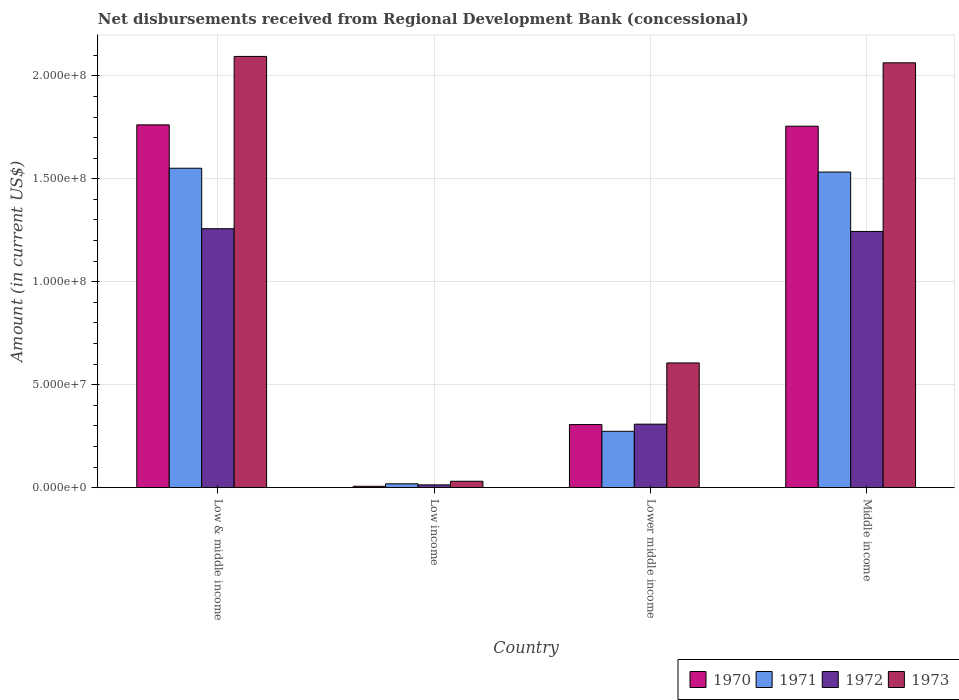How many different coloured bars are there?
Keep it short and to the point. 4. How many groups of bars are there?
Make the answer very short. 4. How many bars are there on the 2nd tick from the left?
Your answer should be compact. 4. How many bars are there on the 3rd tick from the right?
Keep it short and to the point. 4. What is the amount of disbursements received from Regional Development Bank in 1971 in Low & middle income?
Provide a succinct answer. 1.55e+08. Across all countries, what is the maximum amount of disbursements received from Regional Development Bank in 1970?
Make the answer very short. 1.76e+08. Across all countries, what is the minimum amount of disbursements received from Regional Development Bank in 1971?
Offer a very short reply. 1.86e+06. In which country was the amount of disbursements received from Regional Development Bank in 1973 maximum?
Keep it short and to the point. Low & middle income. What is the total amount of disbursements received from Regional Development Bank in 1972 in the graph?
Ensure brevity in your answer.  2.82e+08. What is the difference between the amount of disbursements received from Regional Development Bank in 1973 in Low & middle income and that in Low income?
Give a very brief answer. 2.06e+08. What is the difference between the amount of disbursements received from Regional Development Bank in 1970 in Low income and the amount of disbursements received from Regional Development Bank in 1972 in Low & middle income?
Provide a short and direct response. -1.25e+08. What is the average amount of disbursements received from Regional Development Bank in 1970 per country?
Your answer should be very brief. 9.58e+07. What is the difference between the amount of disbursements received from Regional Development Bank of/in 1973 and amount of disbursements received from Regional Development Bank of/in 1972 in Low & middle income?
Provide a succinct answer. 8.37e+07. In how many countries, is the amount of disbursements received from Regional Development Bank in 1971 greater than 120000000 US$?
Give a very brief answer. 2. What is the ratio of the amount of disbursements received from Regional Development Bank in 1973 in Low & middle income to that in Lower middle income?
Provide a short and direct response. 3.46. Is the amount of disbursements received from Regional Development Bank in 1970 in Low & middle income less than that in Low income?
Keep it short and to the point. No. Is the difference between the amount of disbursements received from Regional Development Bank in 1973 in Low & middle income and Middle income greater than the difference between the amount of disbursements received from Regional Development Bank in 1972 in Low & middle income and Middle income?
Make the answer very short. Yes. What is the difference between the highest and the second highest amount of disbursements received from Regional Development Bank in 1973?
Offer a very short reply. 3.09e+06. What is the difference between the highest and the lowest amount of disbursements received from Regional Development Bank in 1973?
Provide a succinct answer. 2.06e+08. Is it the case that in every country, the sum of the amount of disbursements received from Regional Development Bank in 1970 and amount of disbursements received from Regional Development Bank in 1973 is greater than the sum of amount of disbursements received from Regional Development Bank in 1972 and amount of disbursements received from Regional Development Bank in 1971?
Your answer should be compact. No. What does the 2nd bar from the left in Low income represents?
Provide a succinct answer. 1971. Is it the case that in every country, the sum of the amount of disbursements received from Regional Development Bank in 1970 and amount of disbursements received from Regional Development Bank in 1973 is greater than the amount of disbursements received from Regional Development Bank in 1972?
Your answer should be compact. Yes. Are all the bars in the graph horizontal?
Provide a short and direct response. No. How many legend labels are there?
Give a very brief answer. 4. How are the legend labels stacked?
Offer a terse response. Horizontal. What is the title of the graph?
Your answer should be compact. Net disbursements received from Regional Development Bank (concessional). Does "1996" appear as one of the legend labels in the graph?
Make the answer very short. No. What is the Amount (in current US$) in 1970 in Low & middle income?
Provide a short and direct response. 1.76e+08. What is the Amount (in current US$) in 1971 in Low & middle income?
Your answer should be very brief. 1.55e+08. What is the Amount (in current US$) in 1972 in Low & middle income?
Offer a terse response. 1.26e+08. What is the Amount (in current US$) in 1973 in Low & middle income?
Make the answer very short. 2.09e+08. What is the Amount (in current US$) in 1970 in Low income?
Make the answer very short. 6.47e+05. What is the Amount (in current US$) of 1971 in Low income?
Your answer should be very brief. 1.86e+06. What is the Amount (in current US$) of 1972 in Low income?
Your answer should be compact. 1.33e+06. What is the Amount (in current US$) of 1973 in Low income?
Keep it short and to the point. 3.09e+06. What is the Amount (in current US$) in 1970 in Lower middle income?
Ensure brevity in your answer.  3.06e+07. What is the Amount (in current US$) of 1971 in Lower middle income?
Give a very brief answer. 2.74e+07. What is the Amount (in current US$) in 1972 in Lower middle income?
Offer a terse response. 3.08e+07. What is the Amount (in current US$) in 1973 in Lower middle income?
Your answer should be very brief. 6.06e+07. What is the Amount (in current US$) of 1970 in Middle income?
Make the answer very short. 1.76e+08. What is the Amount (in current US$) of 1971 in Middle income?
Your answer should be compact. 1.53e+08. What is the Amount (in current US$) in 1972 in Middle income?
Offer a very short reply. 1.24e+08. What is the Amount (in current US$) in 1973 in Middle income?
Ensure brevity in your answer.  2.06e+08. Across all countries, what is the maximum Amount (in current US$) of 1970?
Offer a terse response. 1.76e+08. Across all countries, what is the maximum Amount (in current US$) in 1971?
Ensure brevity in your answer.  1.55e+08. Across all countries, what is the maximum Amount (in current US$) of 1972?
Keep it short and to the point. 1.26e+08. Across all countries, what is the maximum Amount (in current US$) of 1973?
Give a very brief answer. 2.09e+08. Across all countries, what is the minimum Amount (in current US$) of 1970?
Offer a very short reply. 6.47e+05. Across all countries, what is the minimum Amount (in current US$) of 1971?
Ensure brevity in your answer.  1.86e+06. Across all countries, what is the minimum Amount (in current US$) of 1972?
Your answer should be very brief. 1.33e+06. Across all countries, what is the minimum Amount (in current US$) of 1973?
Your answer should be very brief. 3.09e+06. What is the total Amount (in current US$) in 1970 in the graph?
Provide a short and direct response. 3.83e+08. What is the total Amount (in current US$) in 1971 in the graph?
Keep it short and to the point. 3.38e+08. What is the total Amount (in current US$) in 1972 in the graph?
Offer a terse response. 2.82e+08. What is the total Amount (in current US$) of 1973 in the graph?
Give a very brief answer. 4.79e+08. What is the difference between the Amount (in current US$) of 1970 in Low & middle income and that in Low income?
Give a very brief answer. 1.76e+08. What is the difference between the Amount (in current US$) of 1971 in Low & middle income and that in Low income?
Your answer should be very brief. 1.53e+08. What is the difference between the Amount (in current US$) in 1972 in Low & middle income and that in Low income?
Your answer should be very brief. 1.24e+08. What is the difference between the Amount (in current US$) in 1973 in Low & middle income and that in Low income?
Provide a succinct answer. 2.06e+08. What is the difference between the Amount (in current US$) in 1970 in Low & middle income and that in Lower middle income?
Your answer should be compact. 1.46e+08. What is the difference between the Amount (in current US$) in 1971 in Low & middle income and that in Lower middle income?
Your answer should be compact. 1.28e+08. What is the difference between the Amount (in current US$) of 1972 in Low & middle income and that in Lower middle income?
Provide a short and direct response. 9.49e+07. What is the difference between the Amount (in current US$) in 1973 in Low & middle income and that in Lower middle income?
Provide a succinct answer. 1.49e+08. What is the difference between the Amount (in current US$) in 1970 in Low & middle income and that in Middle income?
Keep it short and to the point. 6.47e+05. What is the difference between the Amount (in current US$) in 1971 in Low & middle income and that in Middle income?
Ensure brevity in your answer.  1.86e+06. What is the difference between the Amount (in current US$) of 1972 in Low & middle income and that in Middle income?
Your answer should be compact. 1.33e+06. What is the difference between the Amount (in current US$) of 1973 in Low & middle income and that in Middle income?
Provide a short and direct response. 3.09e+06. What is the difference between the Amount (in current US$) in 1970 in Low income and that in Lower middle income?
Your answer should be compact. -3.00e+07. What is the difference between the Amount (in current US$) of 1971 in Low income and that in Lower middle income?
Ensure brevity in your answer.  -2.55e+07. What is the difference between the Amount (in current US$) of 1972 in Low income and that in Lower middle income?
Your answer should be compact. -2.95e+07. What is the difference between the Amount (in current US$) of 1973 in Low income and that in Lower middle income?
Your answer should be compact. -5.75e+07. What is the difference between the Amount (in current US$) in 1970 in Low income and that in Middle income?
Ensure brevity in your answer.  -1.75e+08. What is the difference between the Amount (in current US$) in 1971 in Low income and that in Middle income?
Offer a terse response. -1.51e+08. What is the difference between the Amount (in current US$) in 1972 in Low income and that in Middle income?
Provide a short and direct response. -1.23e+08. What is the difference between the Amount (in current US$) of 1973 in Low income and that in Middle income?
Your answer should be compact. -2.03e+08. What is the difference between the Amount (in current US$) of 1970 in Lower middle income and that in Middle income?
Offer a very short reply. -1.45e+08. What is the difference between the Amount (in current US$) of 1971 in Lower middle income and that in Middle income?
Give a very brief answer. -1.26e+08. What is the difference between the Amount (in current US$) in 1972 in Lower middle income and that in Middle income?
Your answer should be very brief. -9.36e+07. What is the difference between the Amount (in current US$) in 1973 in Lower middle income and that in Middle income?
Your answer should be very brief. -1.46e+08. What is the difference between the Amount (in current US$) in 1970 in Low & middle income and the Amount (in current US$) in 1971 in Low income?
Your response must be concise. 1.74e+08. What is the difference between the Amount (in current US$) of 1970 in Low & middle income and the Amount (in current US$) of 1972 in Low income?
Offer a very short reply. 1.75e+08. What is the difference between the Amount (in current US$) of 1970 in Low & middle income and the Amount (in current US$) of 1973 in Low income?
Provide a succinct answer. 1.73e+08. What is the difference between the Amount (in current US$) in 1971 in Low & middle income and the Amount (in current US$) in 1972 in Low income?
Your answer should be very brief. 1.54e+08. What is the difference between the Amount (in current US$) in 1971 in Low & middle income and the Amount (in current US$) in 1973 in Low income?
Your answer should be compact. 1.52e+08. What is the difference between the Amount (in current US$) in 1972 in Low & middle income and the Amount (in current US$) in 1973 in Low income?
Make the answer very short. 1.23e+08. What is the difference between the Amount (in current US$) of 1970 in Low & middle income and the Amount (in current US$) of 1971 in Lower middle income?
Offer a very short reply. 1.49e+08. What is the difference between the Amount (in current US$) in 1970 in Low & middle income and the Amount (in current US$) in 1972 in Lower middle income?
Your answer should be compact. 1.45e+08. What is the difference between the Amount (in current US$) of 1970 in Low & middle income and the Amount (in current US$) of 1973 in Lower middle income?
Make the answer very short. 1.16e+08. What is the difference between the Amount (in current US$) of 1971 in Low & middle income and the Amount (in current US$) of 1972 in Lower middle income?
Give a very brief answer. 1.24e+08. What is the difference between the Amount (in current US$) of 1971 in Low & middle income and the Amount (in current US$) of 1973 in Lower middle income?
Make the answer very short. 9.46e+07. What is the difference between the Amount (in current US$) in 1972 in Low & middle income and the Amount (in current US$) in 1973 in Lower middle income?
Provide a short and direct response. 6.52e+07. What is the difference between the Amount (in current US$) in 1970 in Low & middle income and the Amount (in current US$) in 1971 in Middle income?
Keep it short and to the point. 2.29e+07. What is the difference between the Amount (in current US$) in 1970 in Low & middle income and the Amount (in current US$) in 1972 in Middle income?
Give a very brief answer. 5.18e+07. What is the difference between the Amount (in current US$) of 1970 in Low & middle income and the Amount (in current US$) of 1973 in Middle income?
Provide a short and direct response. -3.01e+07. What is the difference between the Amount (in current US$) in 1971 in Low & middle income and the Amount (in current US$) in 1972 in Middle income?
Make the answer very short. 3.07e+07. What is the difference between the Amount (in current US$) in 1971 in Low & middle income and the Amount (in current US$) in 1973 in Middle income?
Make the answer very short. -5.12e+07. What is the difference between the Amount (in current US$) of 1972 in Low & middle income and the Amount (in current US$) of 1973 in Middle income?
Your response must be concise. -8.06e+07. What is the difference between the Amount (in current US$) in 1970 in Low income and the Amount (in current US$) in 1971 in Lower middle income?
Keep it short and to the point. -2.67e+07. What is the difference between the Amount (in current US$) of 1970 in Low income and the Amount (in current US$) of 1972 in Lower middle income?
Your answer should be very brief. -3.02e+07. What is the difference between the Amount (in current US$) of 1970 in Low income and the Amount (in current US$) of 1973 in Lower middle income?
Provide a short and direct response. -5.99e+07. What is the difference between the Amount (in current US$) of 1971 in Low income and the Amount (in current US$) of 1972 in Lower middle income?
Make the answer very short. -2.90e+07. What is the difference between the Amount (in current US$) in 1971 in Low income and the Amount (in current US$) in 1973 in Lower middle income?
Provide a short and direct response. -5.87e+07. What is the difference between the Amount (in current US$) of 1972 in Low income and the Amount (in current US$) of 1973 in Lower middle income?
Ensure brevity in your answer.  -5.92e+07. What is the difference between the Amount (in current US$) of 1970 in Low income and the Amount (in current US$) of 1971 in Middle income?
Provide a short and direct response. -1.53e+08. What is the difference between the Amount (in current US$) in 1970 in Low income and the Amount (in current US$) in 1972 in Middle income?
Your answer should be very brief. -1.24e+08. What is the difference between the Amount (in current US$) in 1970 in Low income and the Amount (in current US$) in 1973 in Middle income?
Offer a terse response. -2.06e+08. What is the difference between the Amount (in current US$) in 1971 in Low income and the Amount (in current US$) in 1972 in Middle income?
Offer a terse response. -1.23e+08. What is the difference between the Amount (in current US$) in 1971 in Low income and the Amount (in current US$) in 1973 in Middle income?
Offer a very short reply. -2.04e+08. What is the difference between the Amount (in current US$) of 1972 in Low income and the Amount (in current US$) of 1973 in Middle income?
Offer a terse response. -2.05e+08. What is the difference between the Amount (in current US$) in 1970 in Lower middle income and the Amount (in current US$) in 1971 in Middle income?
Ensure brevity in your answer.  -1.23e+08. What is the difference between the Amount (in current US$) in 1970 in Lower middle income and the Amount (in current US$) in 1972 in Middle income?
Make the answer very short. -9.38e+07. What is the difference between the Amount (in current US$) in 1970 in Lower middle income and the Amount (in current US$) in 1973 in Middle income?
Your answer should be compact. -1.76e+08. What is the difference between the Amount (in current US$) in 1971 in Lower middle income and the Amount (in current US$) in 1972 in Middle income?
Make the answer very short. -9.71e+07. What is the difference between the Amount (in current US$) in 1971 in Lower middle income and the Amount (in current US$) in 1973 in Middle income?
Make the answer very short. -1.79e+08. What is the difference between the Amount (in current US$) in 1972 in Lower middle income and the Amount (in current US$) in 1973 in Middle income?
Ensure brevity in your answer.  -1.76e+08. What is the average Amount (in current US$) of 1970 per country?
Your answer should be compact. 9.58e+07. What is the average Amount (in current US$) in 1971 per country?
Offer a terse response. 8.44e+07. What is the average Amount (in current US$) in 1972 per country?
Offer a terse response. 7.06e+07. What is the average Amount (in current US$) in 1973 per country?
Your response must be concise. 1.20e+08. What is the difference between the Amount (in current US$) of 1970 and Amount (in current US$) of 1971 in Low & middle income?
Your answer should be compact. 2.11e+07. What is the difference between the Amount (in current US$) of 1970 and Amount (in current US$) of 1972 in Low & middle income?
Your answer should be very brief. 5.04e+07. What is the difference between the Amount (in current US$) of 1970 and Amount (in current US$) of 1973 in Low & middle income?
Provide a succinct answer. -3.32e+07. What is the difference between the Amount (in current US$) in 1971 and Amount (in current US$) in 1972 in Low & middle income?
Your answer should be very brief. 2.94e+07. What is the difference between the Amount (in current US$) of 1971 and Amount (in current US$) of 1973 in Low & middle income?
Your response must be concise. -5.43e+07. What is the difference between the Amount (in current US$) in 1972 and Amount (in current US$) in 1973 in Low & middle income?
Provide a succinct answer. -8.37e+07. What is the difference between the Amount (in current US$) in 1970 and Amount (in current US$) in 1971 in Low income?
Make the answer very short. -1.21e+06. What is the difference between the Amount (in current US$) of 1970 and Amount (in current US$) of 1972 in Low income?
Ensure brevity in your answer.  -6.86e+05. What is the difference between the Amount (in current US$) in 1970 and Amount (in current US$) in 1973 in Low income?
Your answer should be very brief. -2.44e+06. What is the difference between the Amount (in current US$) in 1971 and Amount (in current US$) in 1972 in Low income?
Keep it short and to the point. 5.26e+05. What is the difference between the Amount (in current US$) in 1971 and Amount (in current US$) in 1973 in Low income?
Provide a short and direct response. -1.23e+06. What is the difference between the Amount (in current US$) in 1972 and Amount (in current US$) in 1973 in Low income?
Your answer should be compact. -1.76e+06. What is the difference between the Amount (in current US$) in 1970 and Amount (in current US$) in 1971 in Lower middle income?
Keep it short and to the point. 3.27e+06. What is the difference between the Amount (in current US$) in 1970 and Amount (in current US$) in 1972 in Lower middle income?
Your answer should be compact. -2.02e+05. What is the difference between the Amount (in current US$) of 1970 and Amount (in current US$) of 1973 in Lower middle income?
Your response must be concise. -2.99e+07. What is the difference between the Amount (in current US$) in 1971 and Amount (in current US$) in 1972 in Lower middle income?
Your answer should be compact. -3.47e+06. What is the difference between the Amount (in current US$) in 1971 and Amount (in current US$) in 1973 in Lower middle income?
Offer a very short reply. -3.32e+07. What is the difference between the Amount (in current US$) in 1972 and Amount (in current US$) in 1973 in Lower middle income?
Give a very brief answer. -2.97e+07. What is the difference between the Amount (in current US$) in 1970 and Amount (in current US$) in 1971 in Middle income?
Make the answer very short. 2.23e+07. What is the difference between the Amount (in current US$) of 1970 and Amount (in current US$) of 1972 in Middle income?
Keep it short and to the point. 5.11e+07. What is the difference between the Amount (in current US$) in 1970 and Amount (in current US$) in 1973 in Middle income?
Provide a short and direct response. -3.08e+07. What is the difference between the Amount (in current US$) in 1971 and Amount (in current US$) in 1972 in Middle income?
Your response must be concise. 2.88e+07. What is the difference between the Amount (in current US$) in 1971 and Amount (in current US$) in 1973 in Middle income?
Provide a succinct answer. -5.31e+07. What is the difference between the Amount (in current US$) of 1972 and Amount (in current US$) of 1973 in Middle income?
Offer a terse response. -8.19e+07. What is the ratio of the Amount (in current US$) of 1970 in Low & middle income to that in Low income?
Make the answer very short. 272.33. What is the ratio of the Amount (in current US$) of 1971 in Low & middle income to that in Low income?
Offer a terse response. 83.45. What is the ratio of the Amount (in current US$) of 1972 in Low & middle income to that in Low income?
Offer a very short reply. 94.35. What is the ratio of the Amount (in current US$) of 1973 in Low & middle income to that in Low income?
Offer a very short reply. 67.76. What is the ratio of the Amount (in current US$) in 1970 in Low & middle income to that in Lower middle income?
Give a very brief answer. 5.75. What is the ratio of the Amount (in current US$) in 1971 in Low & middle income to that in Lower middle income?
Your response must be concise. 5.67. What is the ratio of the Amount (in current US$) of 1972 in Low & middle income to that in Lower middle income?
Your answer should be very brief. 4.08. What is the ratio of the Amount (in current US$) in 1973 in Low & middle income to that in Lower middle income?
Make the answer very short. 3.46. What is the ratio of the Amount (in current US$) of 1971 in Low & middle income to that in Middle income?
Keep it short and to the point. 1.01. What is the ratio of the Amount (in current US$) in 1972 in Low & middle income to that in Middle income?
Offer a very short reply. 1.01. What is the ratio of the Amount (in current US$) of 1970 in Low income to that in Lower middle income?
Your response must be concise. 0.02. What is the ratio of the Amount (in current US$) of 1971 in Low income to that in Lower middle income?
Give a very brief answer. 0.07. What is the ratio of the Amount (in current US$) in 1972 in Low income to that in Lower middle income?
Your answer should be very brief. 0.04. What is the ratio of the Amount (in current US$) of 1973 in Low income to that in Lower middle income?
Provide a short and direct response. 0.05. What is the ratio of the Amount (in current US$) of 1970 in Low income to that in Middle income?
Your answer should be compact. 0. What is the ratio of the Amount (in current US$) of 1971 in Low income to that in Middle income?
Offer a terse response. 0.01. What is the ratio of the Amount (in current US$) in 1972 in Low income to that in Middle income?
Your answer should be very brief. 0.01. What is the ratio of the Amount (in current US$) in 1973 in Low income to that in Middle income?
Your answer should be very brief. 0.01. What is the ratio of the Amount (in current US$) in 1970 in Lower middle income to that in Middle income?
Keep it short and to the point. 0.17. What is the ratio of the Amount (in current US$) in 1971 in Lower middle income to that in Middle income?
Offer a terse response. 0.18. What is the ratio of the Amount (in current US$) of 1972 in Lower middle income to that in Middle income?
Make the answer very short. 0.25. What is the ratio of the Amount (in current US$) of 1973 in Lower middle income to that in Middle income?
Your answer should be very brief. 0.29. What is the difference between the highest and the second highest Amount (in current US$) in 1970?
Your answer should be very brief. 6.47e+05. What is the difference between the highest and the second highest Amount (in current US$) of 1971?
Your answer should be compact. 1.86e+06. What is the difference between the highest and the second highest Amount (in current US$) of 1972?
Your response must be concise. 1.33e+06. What is the difference between the highest and the second highest Amount (in current US$) of 1973?
Make the answer very short. 3.09e+06. What is the difference between the highest and the lowest Amount (in current US$) of 1970?
Ensure brevity in your answer.  1.76e+08. What is the difference between the highest and the lowest Amount (in current US$) of 1971?
Keep it short and to the point. 1.53e+08. What is the difference between the highest and the lowest Amount (in current US$) of 1972?
Offer a very short reply. 1.24e+08. What is the difference between the highest and the lowest Amount (in current US$) in 1973?
Offer a terse response. 2.06e+08. 